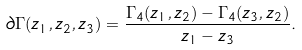Convert formula to latex. <formula><loc_0><loc_0><loc_500><loc_500>\partial \Gamma ( z _ { 1 } , z _ { 2 } , z _ { 3 } ) = \frac { \Gamma _ { 4 } ( z _ { 1 } , z _ { 2 } ) - \Gamma _ { 4 } ( z _ { 3 } , z _ { 2 } ) } { z _ { 1 } - z _ { 3 } } .</formula> 